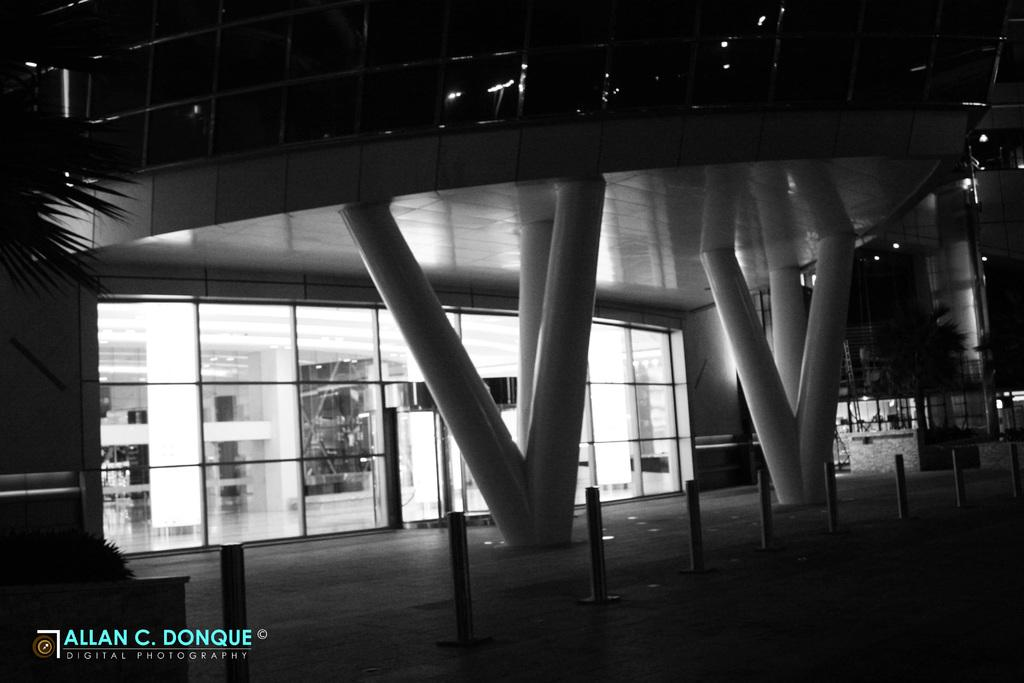What is the main feature in the center of the image? There are safety poles at the center of the image. What type of structure can be seen in the image? There is a building in the image. What natural elements are present in the image? There are trees in the image. Is there any text included in the image? Yes, there is some text printed at the bottom of the image. What type of soda is being advertised in the image? There is no soda or advertisement present in the image. 